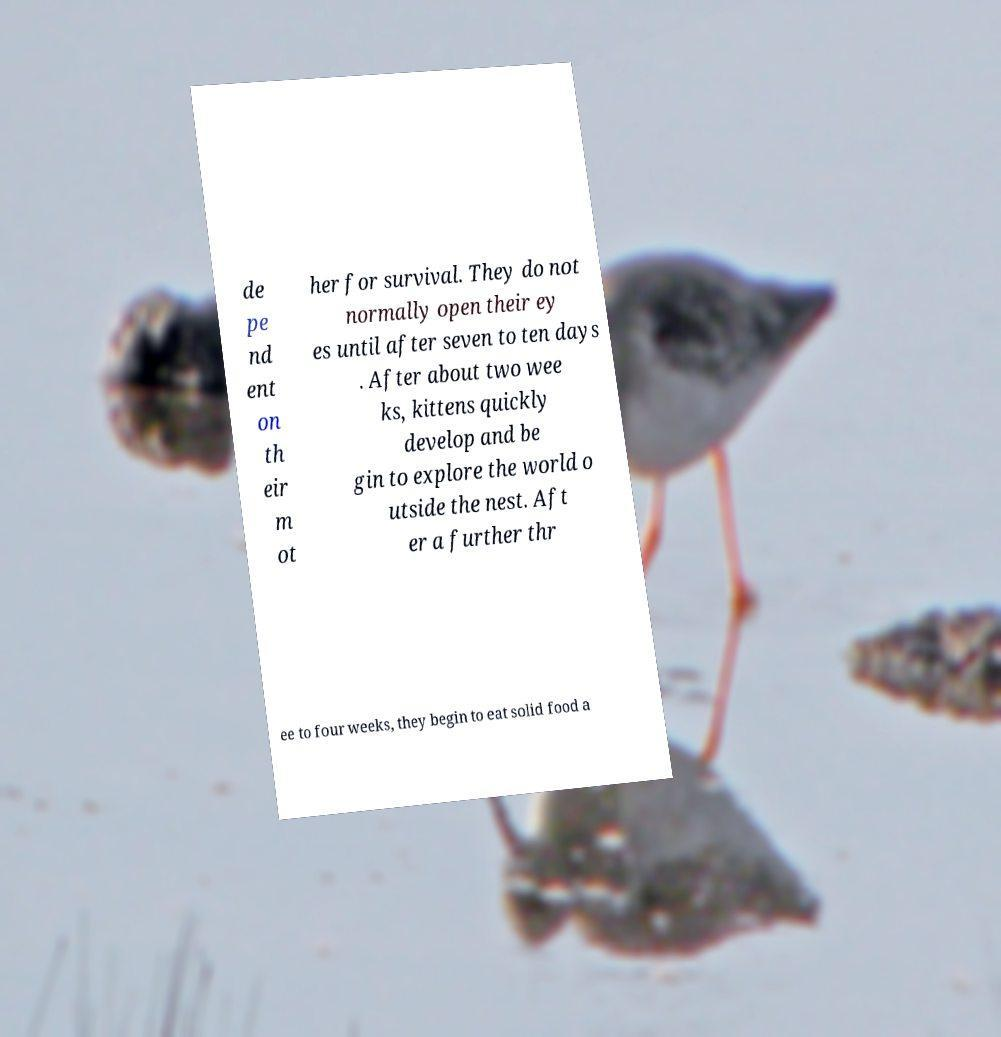There's text embedded in this image that I need extracted. Can you transcribe it verbatim? de pe nd ent on th eir m ot her for survival. They do not normally open their ey es until after seven to ten days . After about two wee ks, kittens quickly develop and be gin to explore the world o utside the nest. Aft er a further thr ee to four weeks, they begin to eat solid food a 